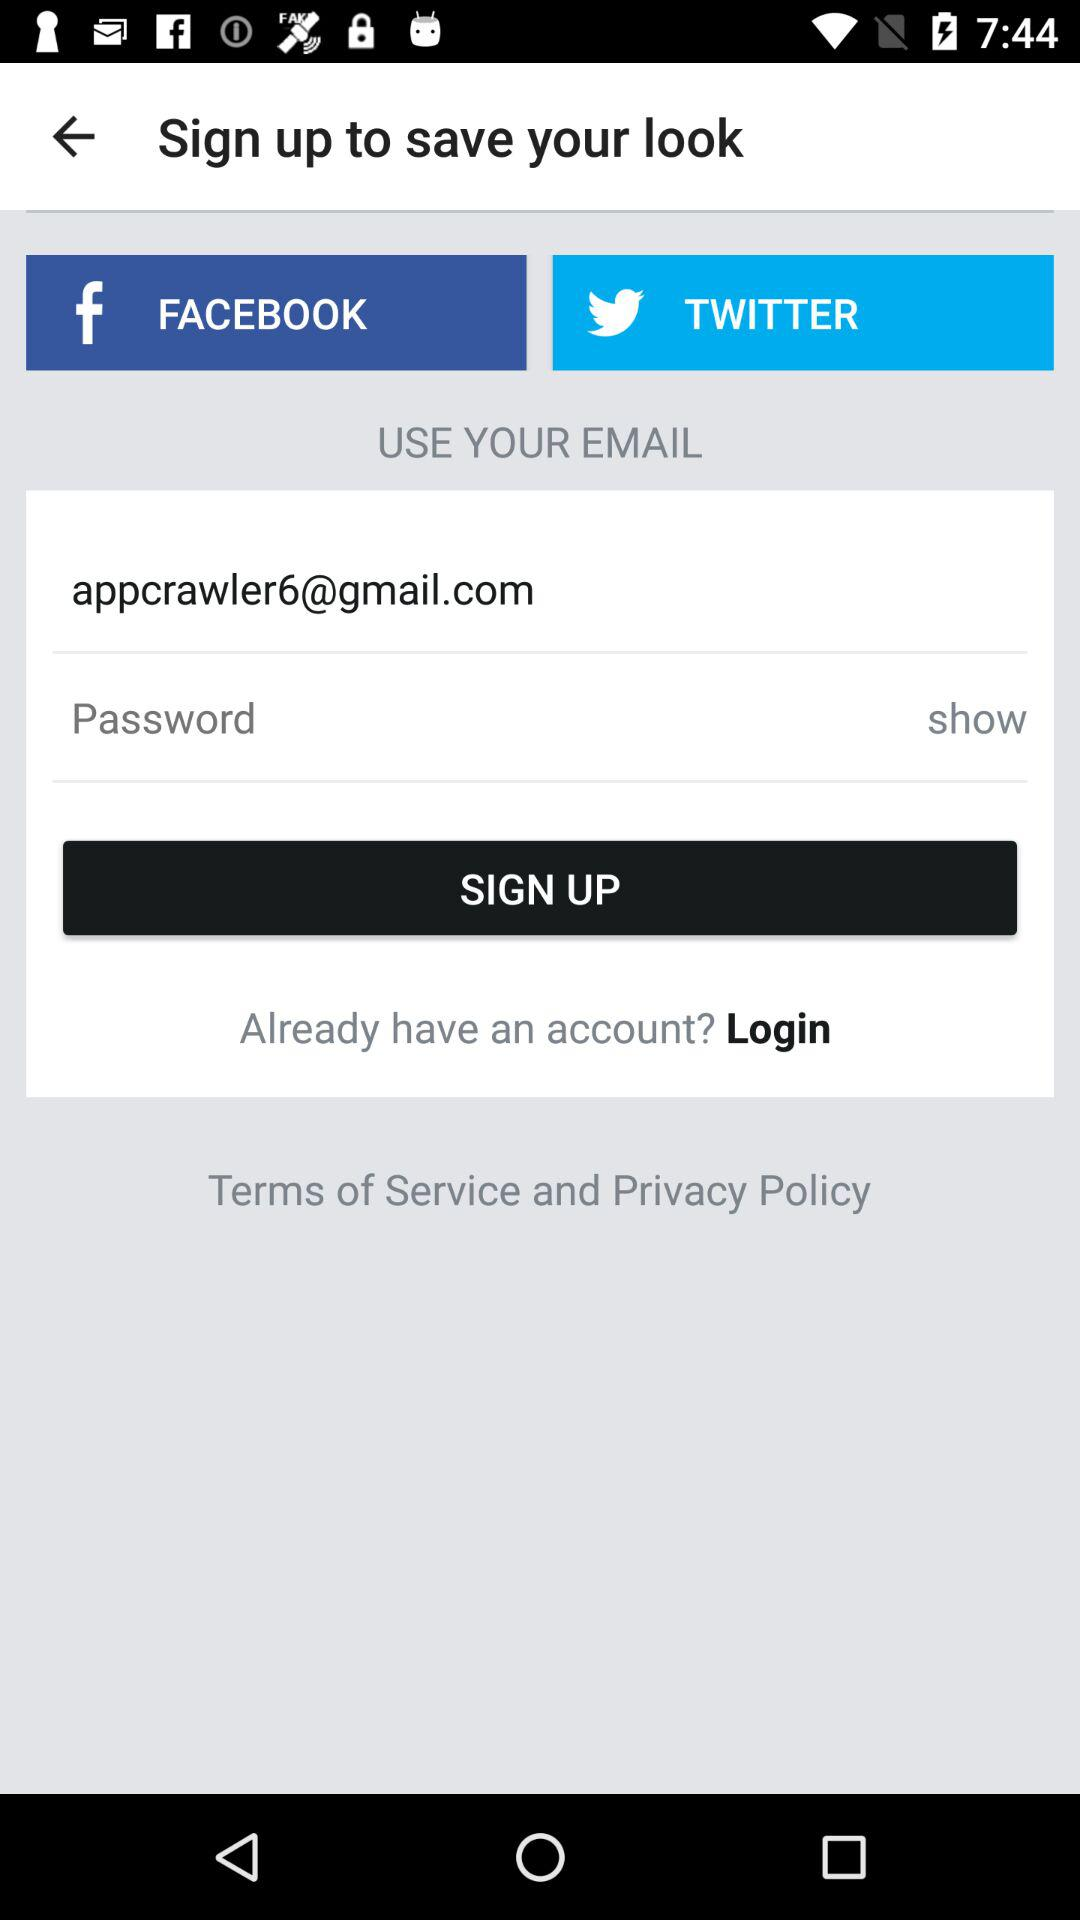How many text inputs are in the sign up form?
Answer the question using a single word or phrase. 2 